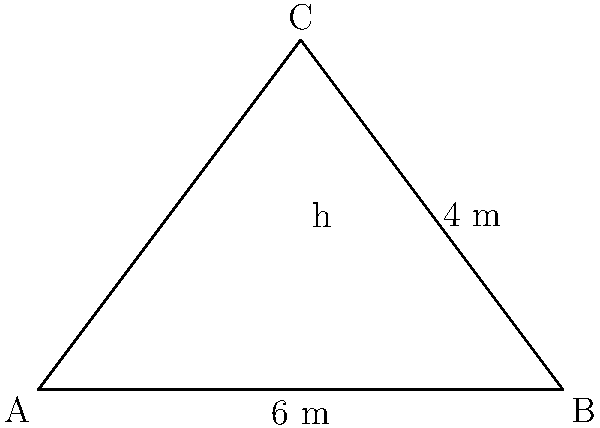For an upcoming music festival in Bucharest, you need to report on the size of a triangular banner advertisement. The banner has a base of 6 meters and a height of 4 meters. What is the area of this triangular banner? To find the area of a triangular banner, we can use the formula:

$$A = \frac{1}{2} \times b \times h$$

Where:
$A$ = Area of the triangle
$b$ = Base of the triangle
$h$ = Height of the triangle

Given:
Base $(b) = 6$ meters
Height $(h) = 4$ meters

Let's substitute these values into the formula:

$$A = \frac{1}{2} \times 6 \times 4$$

Now, let's calculate:

$$A = \frac{1}{2} \times 24 = 12$$

Therefore, the area of the triangular banner is 12 square meters.
Answer: 12 m² 